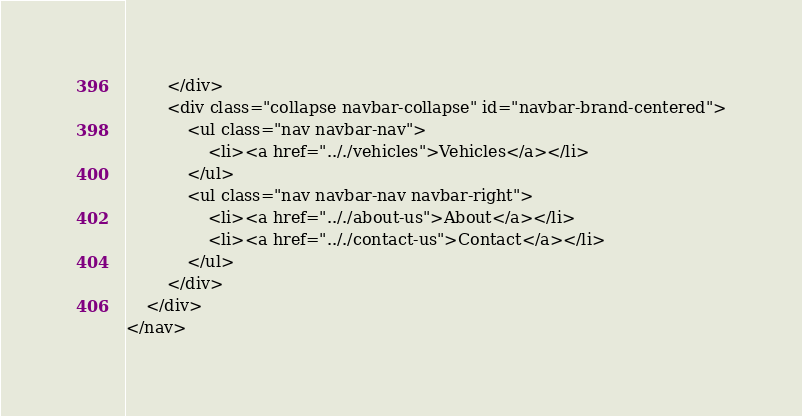<code> <loc_0><loc_0><loc_500><loc_500><_PHP_>		</div>
		<div class="collapse navbar-collapse" id="navbar-brand-centered">
			<ul class="nav navbar-nav">
				<li><a href=".././vehicles">Vehicles</a></li>
			</ul>
			<ul class="nav navbar-nav navbar-right">
				<li><a href=".././about-us">About</a></li>
				<li><a href=".././contact-us">Contact</a></li>
			</ul>
		</div>
	</div>
</nav>
</code> 